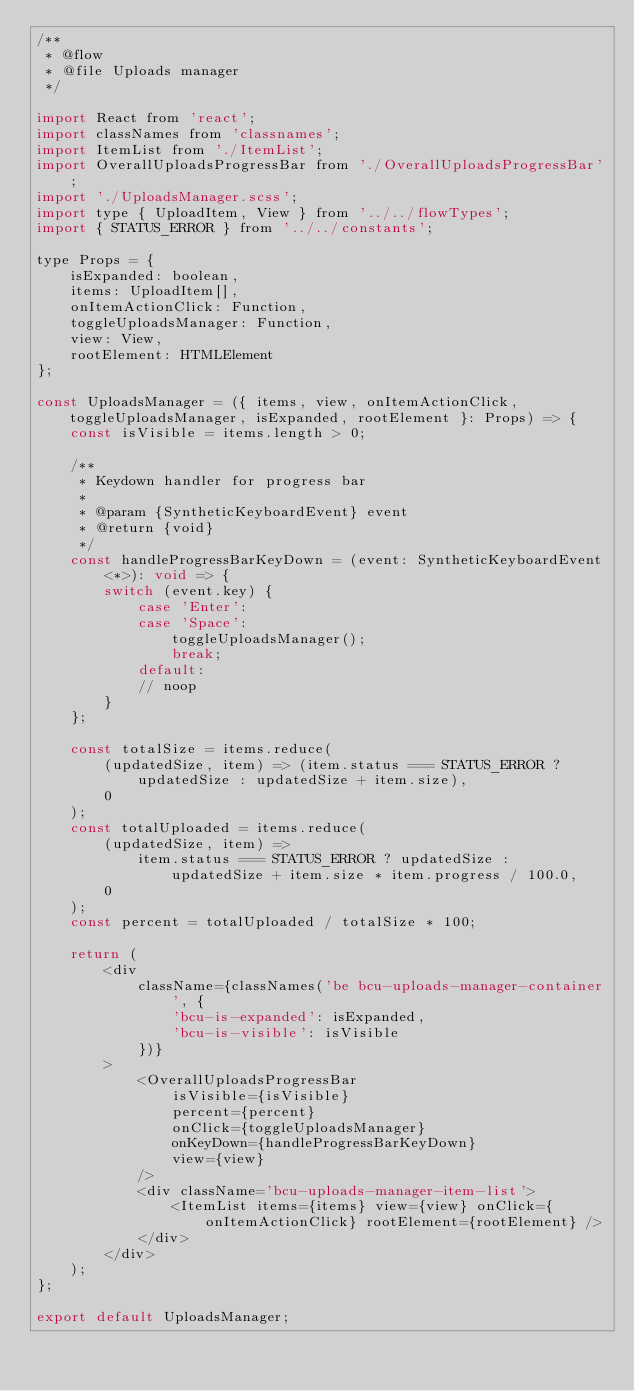<code> <loc_0><loc_0><loc_500><loc_500><_JavaScript_>/**
 * @flow
 * @file Uploads manager
 */

import React from 'react';
import classNames from 'classnames';
import ItemList from './ItemList';
import OverallUploadsProgressBar from './OverallUploadsProgressBar';
import './UploadsManager.scss';
import type { UploadItem, View } from '../../flowTypes';
import { STATUS_ERROR } from '../../constants';

type Props = {
    isExpanded: boolean,
    items: UploadItem[],
    onItemActionClick: Function,
    toggleUploadsManager: Function,
    view: View,
    rootElement: HTMLElement
};

const UploadsManager = ({ items, view, onItemActionClick, toggleUploadsManager, isExpanded, rootElement }: Props) => {
    const isVisible = items.length > 0;

    /**
     * Keydown handler for progress bar
     *
     * @param {SyntheticKeyboardEvent} event
     * @return {void}
     */
    const handleProgressBarKeyDown = (event: SyntheticKeyboardEvent<*>): void => {
        switch (event.key) {
            case 'Enter':
            case 'Space':
                toggleUploadsManager();
                break;
            default:
            // noop
        }
    };

    const totalSize = items.reduce(
        (updatedSize, item) => (item.status === STATUS_ERROR ? updatedSize : updatedSize + item.size),
        0
    );
    const totalUploaded = items.reduce(
        (updatedSize, item) =>
            item.status === STATUS_ERROR ? updatedSize : updatedSize + item.size * item.progress / 100.0,
        0
    );
    const percent = totalUploaded / totalSize * 100;

    return (
        <div
            className={classNames('be bcu-uploads-manager-container', {
                'bcu-is-expanded': isExpanded,
                'bcu-is-visible': isVisible
            })}
        >
            <OverallUploadsProgressBar
                isVisible={isVisible}
                percent={percent}
                onClick={toggleUploadsManager}
                onKeyDown={handleProgressBarKeyDown}
                view={view}
            />
            <div className='bcu-uploads-manager-item-list'>
                <ItemList items={items} view={view} onClick={onItemActionClick} rootElement={rootElement} />
            </div>
        </div>
    );
};

export default UploadsManager;
</code> 